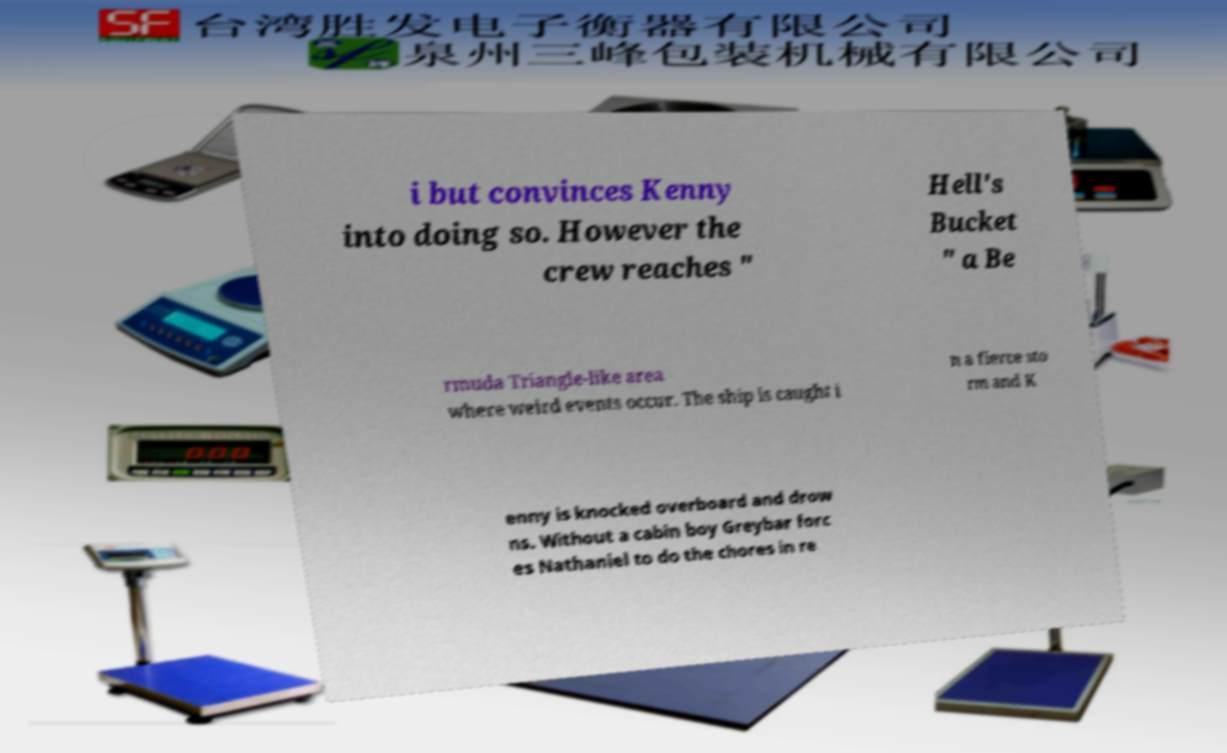Can you read and provide the text displayed in the image?This photo seems to have some interesting text. Can you extract and type it out for me? i but convinces Kenny into doing so. However the crew reaches " Hell's Bucket " a Be rmuda Triangle-like area where weird events occur. The ship is caught i n a fierce sto rm and K enny is knocked overboard and drow ns. Without a cabin boy Greybar forc es Nathaniel to do the chores in re 